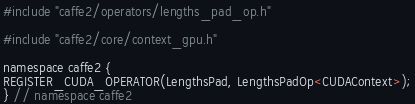Convert code to text. <code><loc_0><loc_0><loc_500><loc_500><_Cuda_>#include "caffe2/operators/lengths_pad_op.h"

#include "caffe2/core/context_gpu.h"

namespace caffe2 {
REGISTER_CUDA_OPERATOR(LengthsPad, LengthsPadOp<CUDAContext>);
} // namespace caffe2
</code> 